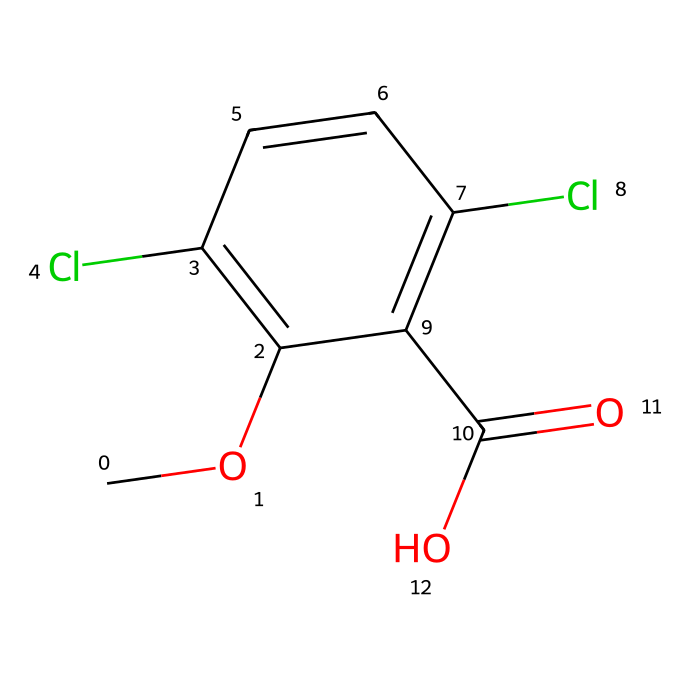What is the core structural feature of dicamba? The core structure consists of a benzene ring substituted with multiple functional groups; specifically, a methoxy group, two chlorine atoms, and a carboxylic acid group.
Answer: benzene ring How many chlorine atoms are present in dicamba? The SMILES representation shows two instances of 'Cl', indicating the presence of two chlorine atoms within the chemical structure.
Answer: two What functional group is present at the end of the dicamba molecule? Looking at the terminal portion of the SMILES, the 'C(=O)O' indicates that there's a carboxylic acid functional group at the end of the structure.
Answer: carboxylic acid How many carbon atoms are in the dicamba molecule? Counting the carbon atoms in the SMILES representation, there are six carbon atoms in the benzene ring, one in the methoxy group, and one in the carboxylic acid group, making a total of eight carbons.
Answer: eight What type of herbicide is dicamba classified as? Dicamba is classified as a selective herbicide, which targets broadleaf weeds without harming grasses, based on its chemical action and structure.
Answer: selective herbicide What impact do the chlorine substituents have in dicamba? The chlorine atoms enhance the herbicide's efficacy and stability in various environmental conditions, which is common for many chlorinated organic compounds used in herbicides.
Answer: increase stability 